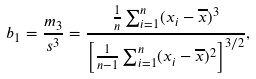Convert formula to latex. <formula><loc_0><loc_0><loc_500><loc_500>b _ { 1 } = { \frac { m _ { 3 } } { s ^ { 3 } } } = { \frac { { \frac { 1 } { n } } \sum _ { i = 1 } ^ { n } ( x _ { i } - { \overline { x } } ) ^ { 3 } } { \left [ { \frac { 1 } { n - 1 } } \sum _ { i = 1 } ^ { n } ( x _ { i } - { \overline { x } } ) ^ { 2 } \right ] ^ { 3 / 2 } } } ,</formula> 